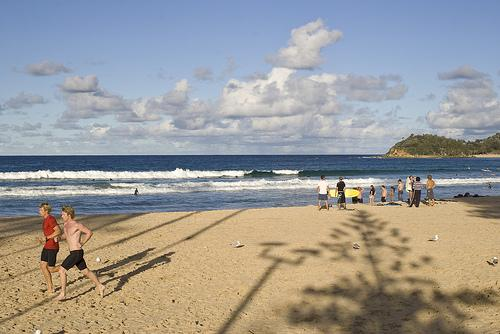Describe the clothing of the two men running on the beach. One man is shirtless, wearing only black shorts, while the other man is wearing a red t-shirt and shorts. Based on the context, what can we infer about the weather in the image? The weather appears to be sunny and warm as people are enjoying outdoor activities at the beach. What predominant colors stand out in this image, and where can they be found? Blue, found in the sky and water; yellow, found in the surfboard; and red, found in a man's t-shirt. What is the primary color of the surfboard being held by a man? The surfboard is yellow in color. Identify and describe two distinctive elements in the sky. The sky is blue and has white clouds. Analyze the image and mention any possible safety concerns for the people at the beach. There doesn't seem to be any safety concerns, as the people are engaged in typical beach activities in a relaxed environment; however, they should be cautious of the waves in the ocean. In this image, describe the overall sentiment and feelings it might evoke. The image conveys a relaxed and joyful atmosphere, as people enjoy various activities at a beautiful beach with an impressive natural backdrop. Summarize the overall image content in one sentence. People are enjoying a beach day with some running, swimming, and holding a surfboard, while the ocean, mountain, and sky create a picturesque background. Identify the type of terrain in the distance and describe its characteristics. There is a mountain in the distance, which has trees on it and appears to be an island. How many people are mentioned to be running on the beach? There are two men running on the beach. 